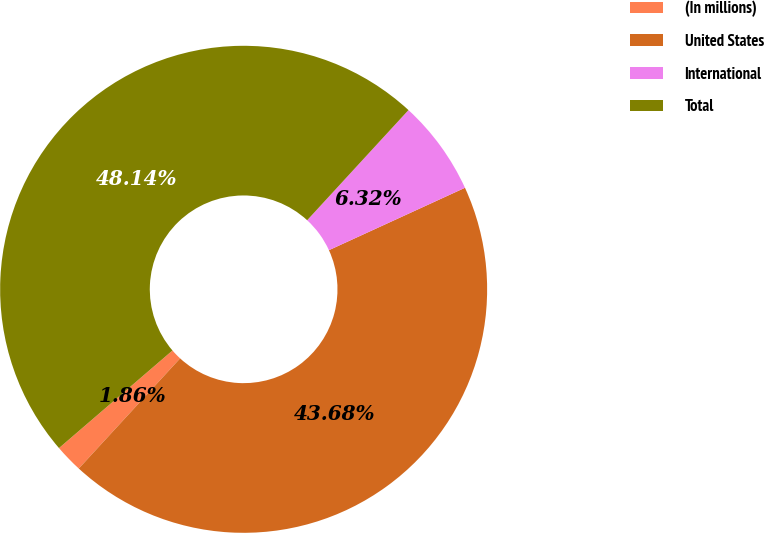Convert chart. <chart><loc_0><loc_0><loc_500><loc_500><pie_chart><fcel>(In millions)<fcel>United States<fcel>International<fcel>Total<nl><fcel>1.86%<fcel>43.68%<fcel>6.32%<fcel>48.14%<nl></chart> 